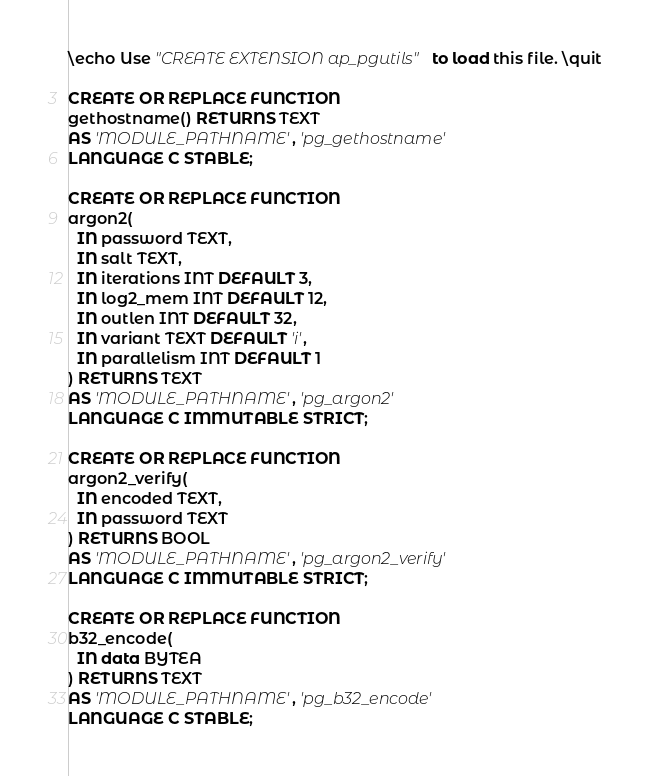<code> <loc_0><loc_0><loc_500><loc_500><_SQL_>\echo Use "CREATE EXTENSION ap_pgutils" to load this file. \quit

CREATE OR REPLACE FUNCTION
gethostname() RETURNS TEXT
AS 'MODULE_PATHNAME', 'pg_gethostname'
LANGUAGE C STABLE;

CREATE OR REPLACE FUNCTION
argon2(
  IN password TEXT,
  IN salt TEXT,
  IN iterations INT DEFAULT 3,
  IN log2_mem INT DEFAULT 12,
  IN outlen INT DEFAULT 32,
  IN variant TEXT DEFAULT 'i',
  IN parallelism INT DEFAULT 1
) RETURNS TEXT
AS 'MODULE_PATHNAME', 'pg_argon2'
LANGUAGE C IMMUTABLE STRICT;

CREATE OR REPLACE FUNCTION
argon2_verify(
  IN encoded TEXT,
  IN password TEXT
) RETURNS BOOL
AS 'MODULE_PATHNAME', 'pg_argon2_verify'
LANGUAGE C IMMUTABLE STRICT;

CREATE OR REPLACE FUNCTION
b32_encode(
  IN data BYTEA
) RETURNS TEXT
AS 'MODULE_PATHNAME', 'pg_b32_encode'
LANGUAGE C STABLE;
</code> 